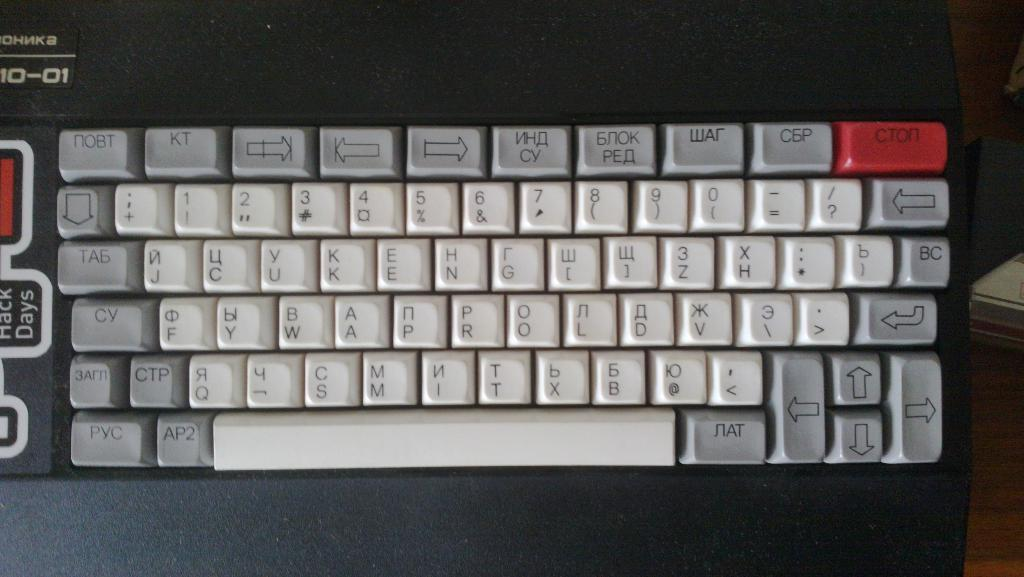<image>
Relay a brief, clear account of the picture shown. Black and white keyboard with the number 10-01 on the top left. 